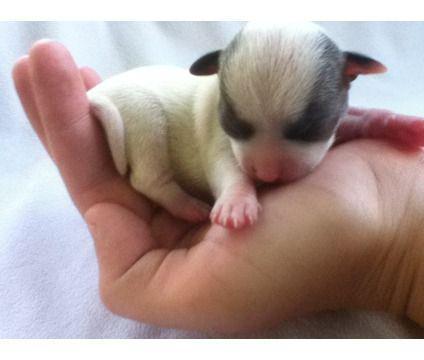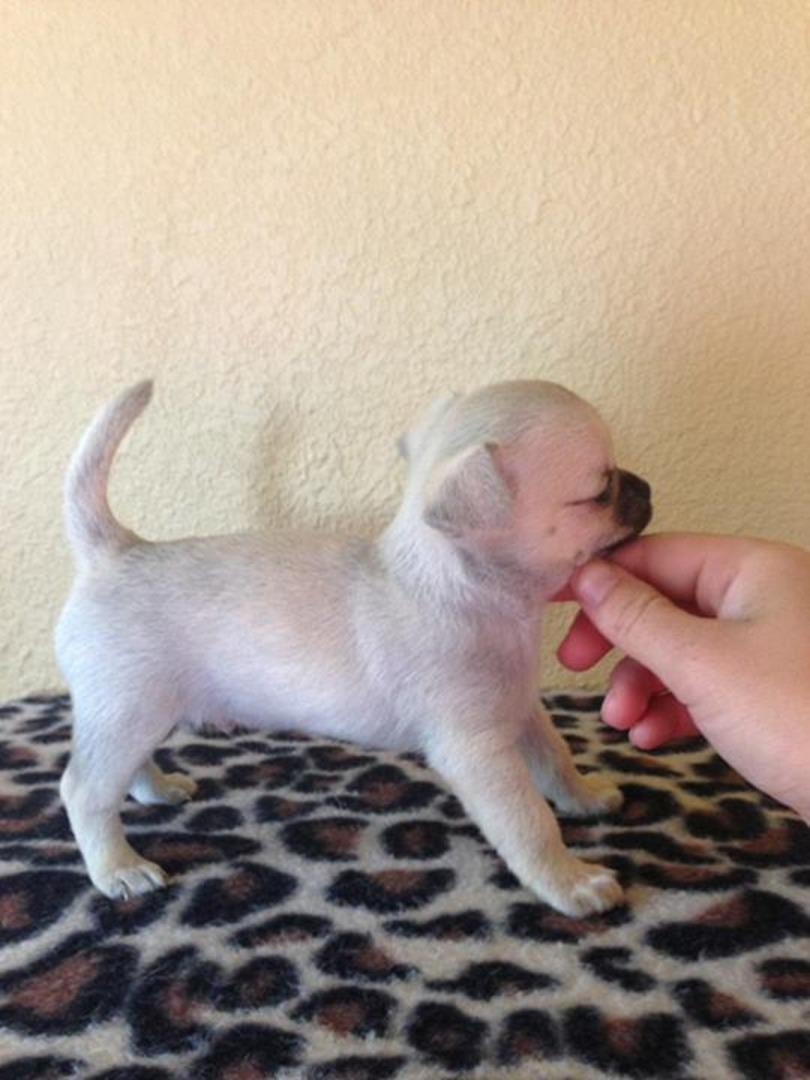The first image is the image on the left, the second image is the image on the right. Examine the images to the left and right. Is the description "The dog in the image on the left is wearing a collar." accurate? Answer yes or no. No. The first image is the image on the left, the second image is the image on the right. Analyze the images presented: Is the assertion "One dog is wearing the kind of item people wear." valid? Answer yes or no. No. 